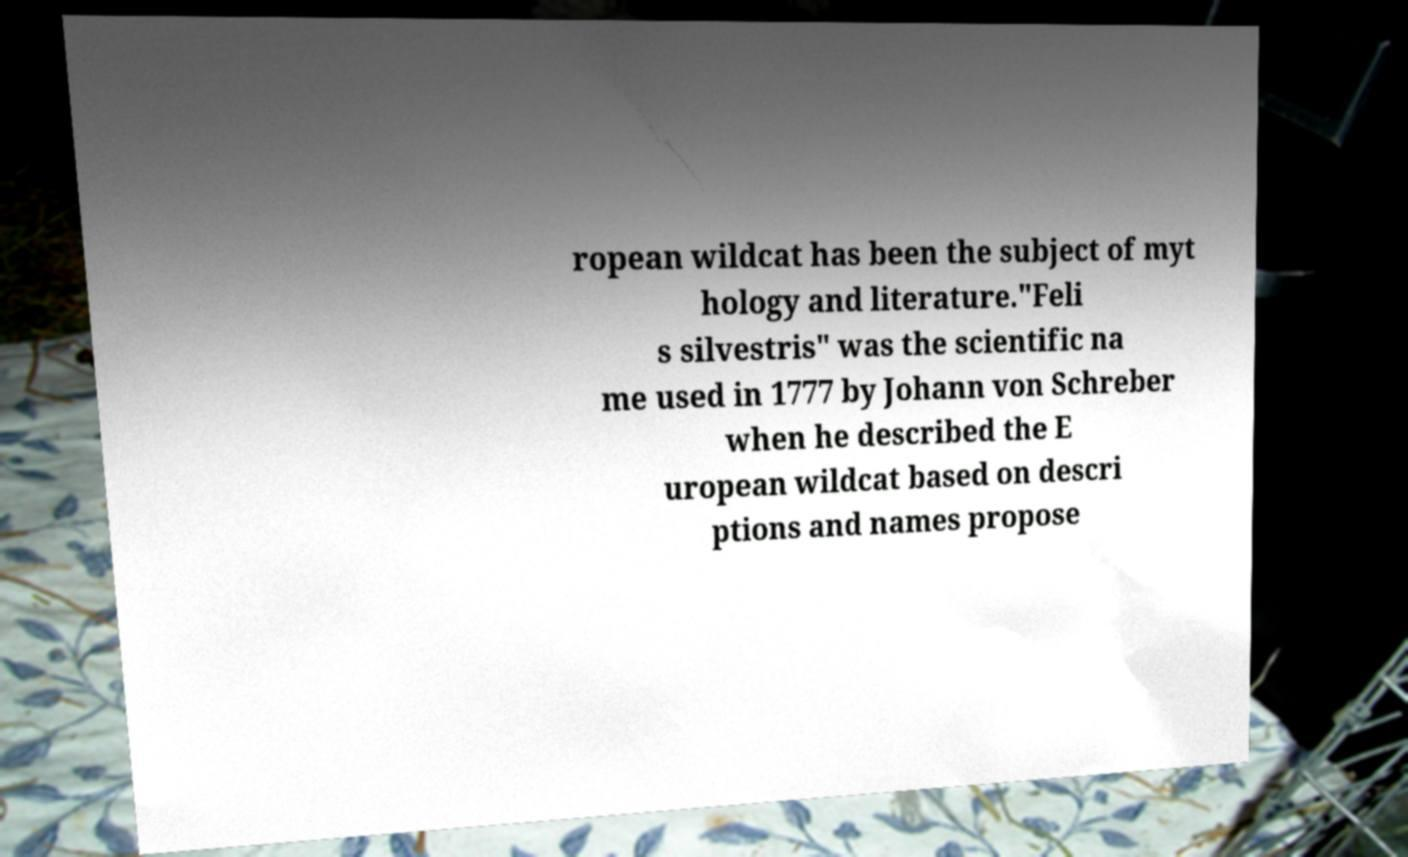Please identify and transcribe the text found in this image. ropean wildcat has been the subject of myt hology and literature."Feli s silvestris" was the scientific na me used in 1777 by Johann von Schreber when he described the E uropean wildcat based on descri ptions and names propose 